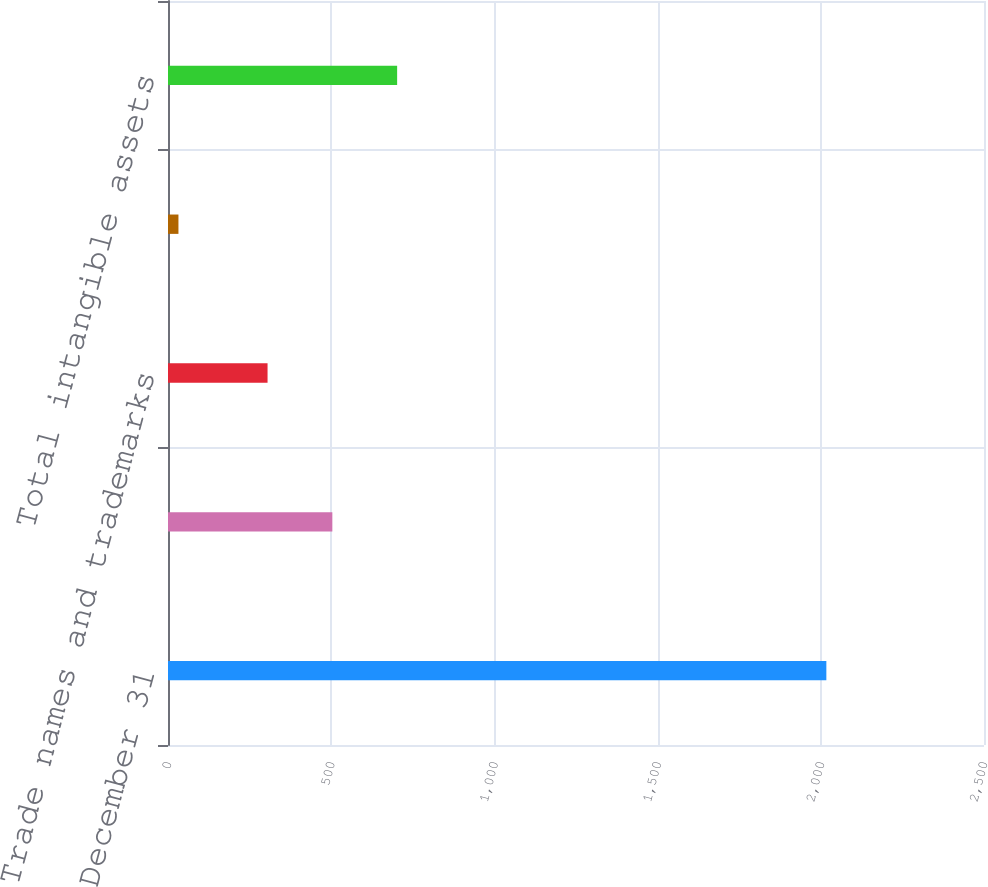Convert chart to OTSL. <chart><loc_0><loc_0><loc_500><loc_500><bar_chart><fcel>December 31<fcel>Contract and program<fcel>Trade names and trademarks<fcel>Technology and software<fcel>Total intangible assets<nl><fcel>2017<fcel>503.5<fcel>305<fcel>32<fcel>702<nl></chart> 